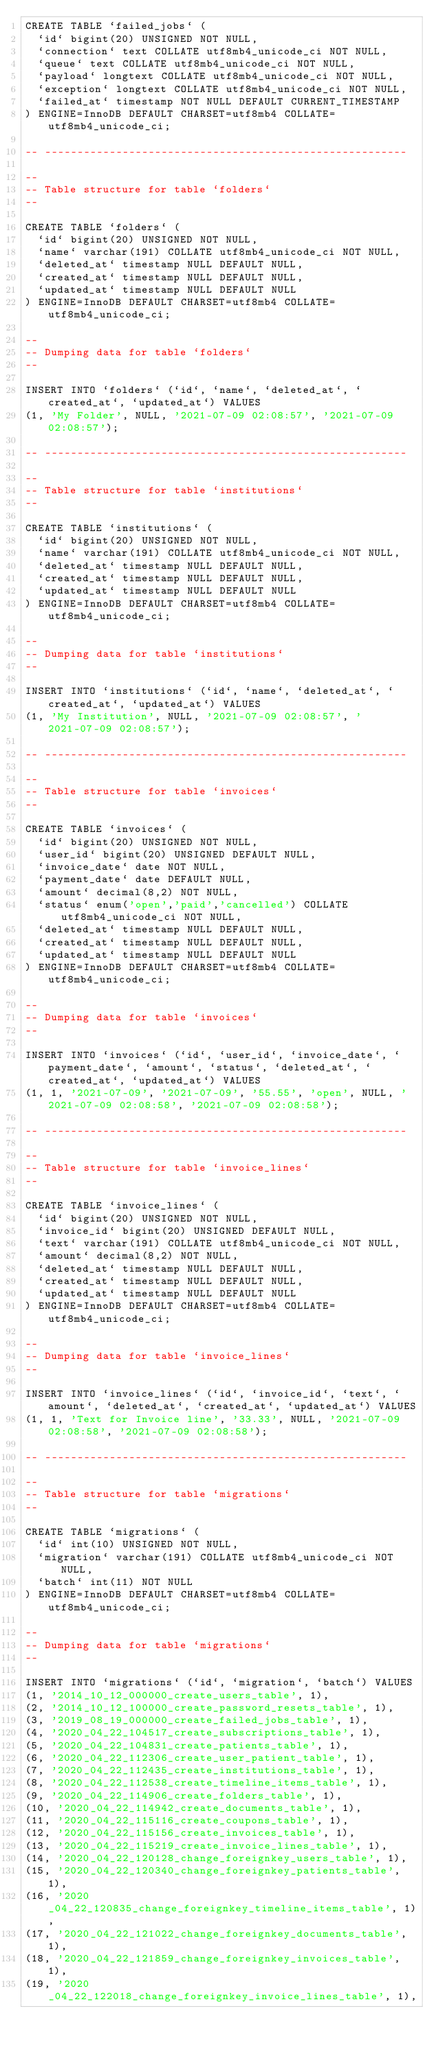<code> <loc_0><loc_0><loc_500><loc_500><_SQL_>CREATE TABLE `failed_jobs` (
  `id` bigint(20) UNSIGNED NOT NULL,
  `connection` text COLLATE utf8mb4_unicode_ci NOT NULL,
  `queue` text COLLATE utf8mb4_unicode_ci NOT NULL,
  `payload` longtext COLLATE utf8mb4_unicode_ci NOT NULL,
  `exception` longtext COLLATE utf8mb4_unicode_ci NOT NULL,
  `failed_at` timestamp NOT NULL DEFAULT CURRENT_TIMESTAMP
) ENGINE=InnoDB DEFAULT CHARSET=utf8mb4 COLLATE=utf8mb4_unicode_ci;

-- --------------------------------------------------------

--
-- Table structure for table `folders`
--

CREATE TABLE `folders` (
  `id` bigint(20) UNSIGNED NOT NULL,
  `name` varchar(191) COLLATE utf8mb4_unicode_ci NOT NULL,
  `deleted_at` timestamp NULL DEFAULT NULL,
  `created_at` timestamp NULL DEFAULT NULL,
  `updated_at` timestamp NULL DEFAULT NULL
) ENGINE=InnoDB DEFAULT CHARSET=utf8mb4 COLLATE=utf8mb4_unicode_ci;

--
-- Dumping data for table `folders`
--

INSERT INTO `folders` (`id`, `name`, `deleted_at`, `created_at`, `updated_at`) VALUES
(1, 'My Folder', NULL, '2021-07-09 02:08:57', '2021-07-09 02:08:57');

-- --------------------------------------------------------

--
-- Table structure for table `institutions`
--

CREATE TABLE `institutions` (
  `id` bigint(20) UNSIGNED NOT NULL,
  `name` varchar(191) COLLATE utf8mb4_unicode_ci NOT NULL,
  `deleted_at` timestamp NULL DEFAULT NULL,
  `created_at` timestamp NULL DEFAULT NULL,
  `updated_at` timestamp NULL DEFAULT NULL
) ENGINE=InnoDB DEFAULT CHARSET=utf8mb4 COLLATE=utf8mb4_unicode_ci;

--
-- Dumping data for table `institutions`
--

INSERT INTO `institutions` (`id`, `name`, `deleted_at`, `created_at`, `updated_at`) VALUES
(1, 'My Institution', NULL, '2021-07-09 02:08:57', '2021-07-09 02:08:57');

-- --------------------------------------------------------

--
-- Table structure for table `invoices`
--

CREATE TABLE `invoices` (
  `id` bigint(20) UNSIGNED NOT NULL,
  `user_id` bigint(20) UNSIGNED DEFAULT NULL,
  `invoice_date` date NOT NULL,
  `payment_date` date DEFAULT NULL,
  `amount` decimal(8,2) NOT NULL,
  `status` enum('open','paid','cancelled') COLLATE utf8mb4_unicode_ci NOT NULL,
  `deleted_at` timestamp NULL DEFAULT NULL,
  `created_at` timestamp NULL DEFAULT NULL,
  `updated_at` timestamp NULL DEFAULT NULL
) ENGINE=InnoDB DEFAULT CHARSET=utf8mb4 COLLATE=utf8mb4_unicode_ci;

--
-- Dumping data for table `invoices`
--

INSERT INTO `invoices` (`id`, `user_id`, `invoice_date`, `payment_date`, `amount`, `status`, `deleted_at`, `created_at`, `updated_at`) VALUES
(1, 1, '2021-07-09', '2021-07-09', '55.55', 'open', NULL, '2021-07-09 02:08:58', '2021-07-09 02:08:58');

-- --------------------------------------------------------

--
-- Table structure for table `invoice_lines`
--

CREATE TABLE `invoice_lines` (
  `id` bigint(20) UNSIGNED NOT NULL,
  `invoice_id` bigint(20) UNSIGNED DEFAULT NULL,
  `text` varchar(191) COLLATE utf8mb4_unicode_ci NOT NULL,
  `amount` decimal(8,2) NOT NULL,
  `deleted_at` timestamp NULL DEFAULT NULL,
  `created_at` timestamp NULL DEFAULT NULL,
  `updated_at` timestamp NULL DEFAULT NULL
) ENGINE=InnoDB DEFAULT CHARSET=utf8mb4 COLLATE=utf8mb4_unicode_ci;

--
-- Dumping data for table `invoice_lines`
--

INSERT INTO `invoice_lines` (`id`, `invoice_id`, `text`, `amount`, `deleted_at`, `created_at`, `updated_at`) VALUES
(1, 1, 'Text for Invoice line', '33.33', NULL, '2021-07-09 02:08:58', '2021-07-09 02:08:58');

-- --------------------------------------------------------

--
-- Table structure for table `migrations`
--

CREATE TABLE `migrations` (
  `id` int(10) UNSIGNED NOT NULL,
  `migration` varchar(191) COLLATE utf8mb4_unicode_ci NOT NULL,
  `batch` int(11) NOT NULL
) ENGINE=InnoDB DEFAULT CHARSET=utf8mb4 COLLATE=utf8mb4_unicode_ci;

--
-- Dumping data for table `migrations`
--

INSERT INTO `migrations` (`id`, `migration`, `batch`) VALUES
(1, '2014_10_12_000000_create_users_table', 1),
(2, '2014_10_12_100000_create_password_resets_table', 1),
(3, '2019_08_19_000000_create_failed_jobs_table', 1),
(4, '2020_04_22_104517_create_subscriptions_table', 1),
(5, '2020_04_22_104831_create_patients_table', 1),
(6, '2020_04_22_112306_create_user_patient_table', 1),
(7, '2020_04_22_112435_create_institutions_table', 1),
(8, '2020_04_22_112538_create_timeline_items_table', 1),
(9, '2020_04_22_114906_create_folders_table', 1),
(10, '2020_04_22_114942_create_documents_table', 1),
(11, '2020_04_22_115116_create_coupons_table', 1),
(12, '2020_04_22_115156_create_invoices_table', 1),
(13, '2020_04_22_115219_create_invoice_lines_table', 1),
(14, '2020_04_22_120128_change_foreignkey_users_table', 1),
(15, '2020_04_22_120340_change_foreignkey_patients_table', 1),
(16, '2020_04_22_120835_change_foreignkey_timeline_items_table', 1),
(17, '2020_04_22_121022_change_foreignkey_documents_table', 1),
(18, '2020_04_22_121859_change_foreignkey_invoices_table', 1),
(19, '2020_04_22_122018_change_foreignkey_invoice_lines_table', 1),</code> 